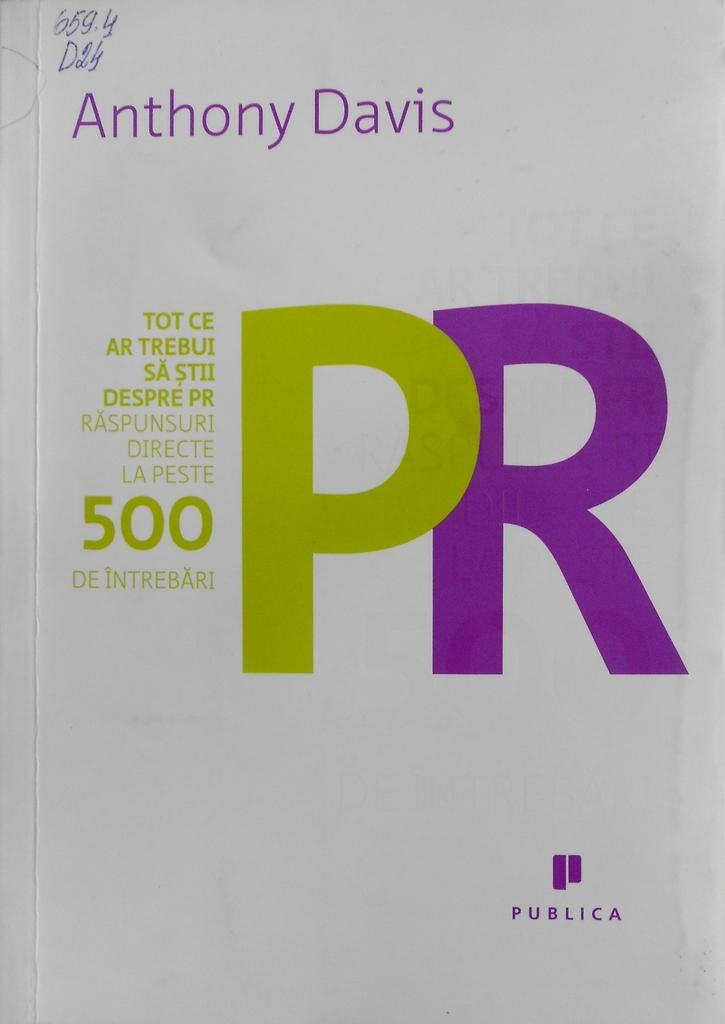What is the color of the poster in the image? The poster in the image is white. What text is printed on the poster? The name "ANTHONY DAVIS" is printed on the poster. What type of plants can be seen growing on the poster? There are no plants visible on the poster; it features the name "ANTHONY DAVIS" printed in white on a white background. 